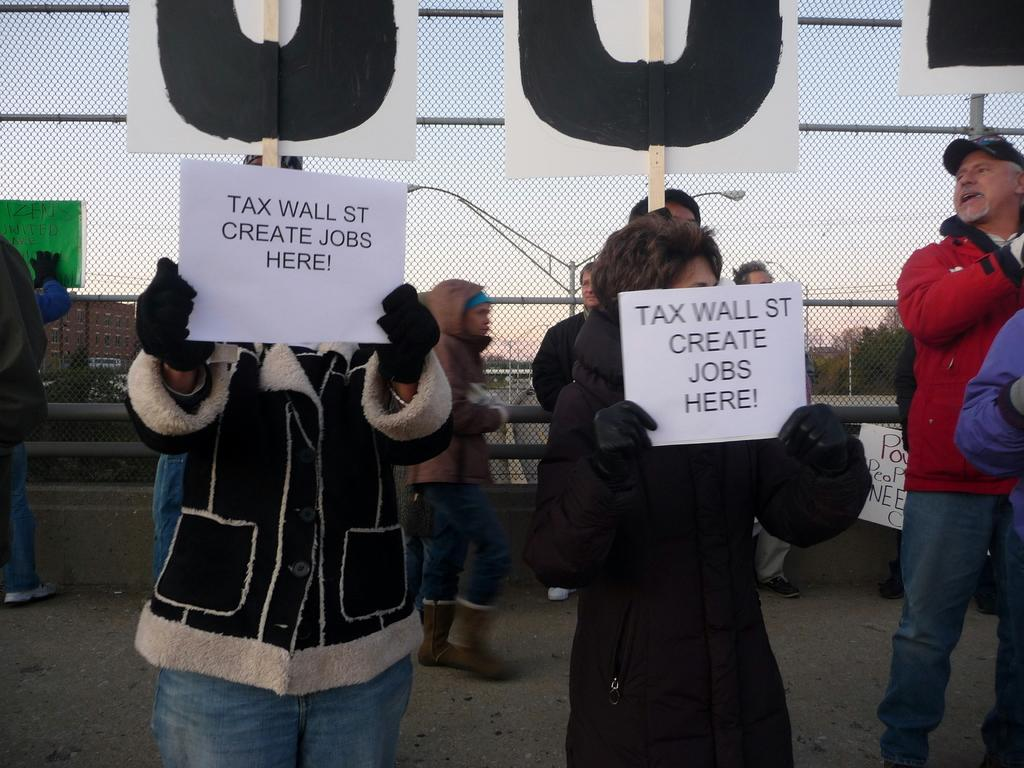What are the people in the image doing? The people in the image are standing. What are some of the people holding in their hands? Some of the people are holding placards in their hands. What can be seen in the background of the image? There is a fence and trees in the background of the image, as well as other unspecified objects. What type of meat is being cooked in the circle in the image? There is no meat or circle present in the image. 